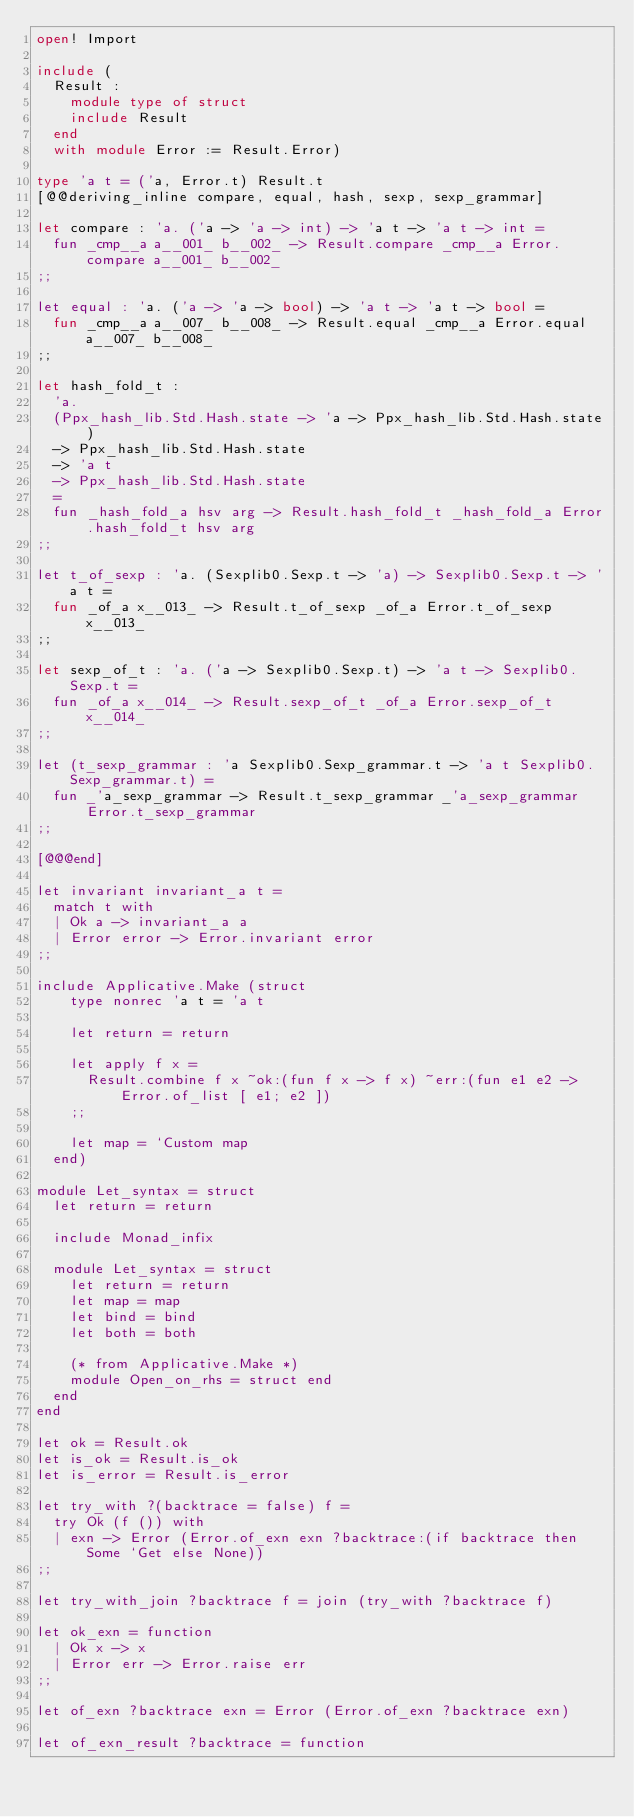<code> <loc_0><loc_0><loc_500><loc_500><_OCaml_>open! Import

include (
  Result :
    module type of struct
    include Result
  end
  with module Error := Result.Error)

type 'a t = ('a, Error.t) Result.t
[@@deriving_inline compare, equal, hash, sexp, sexp_grammar]

let compare : 'a. ('a -> 'a -> int) -> 'a t -> 'a t -> int =
  fun _cmp__a a__001_ b__002_ -> Result.compare _cmp__a Error.compare a__001_ b__002_
;;

let equal : 'a. ('a -> 'a -> bool) -> 'a t -> 'a t -> bool =
  fun _cmp__a a__007_ b__008_ -> Result.equal _cmp__a Error.equal a__007_ b__008_
;;

let hash_fold_t :
  'a.
  (Ppx_hash_lib.Std.Hash.state -> 'a -> Ppx_hash_lib.Std.Hash.state)
  -> Ppx_hash_lib.Std.Hash.state
  -> 'a t
  -> Ppx_hash_lib.Std.Hash.state
  =
  fun _hash_fold_a hsv arg -> Result.hash_fold_t _hash_fold_a Error.hash_fold_t hsv arg
;;

let t_of_sexp : 'a. (Sexplib0.Sexp.t -> 'a) -> Sexplib0.Sexp.t -> 'a t =
  fun _of_a x__013_ -> Result.t_of_sexp _of_a Error.t_of_sexp x__013_
;;

let sexp_of_t : 'a. ('a -> Sexplib0.Sexp.t) -> 'a t -> Sexplib0.Sexp.t =
  fun _of_a x__014_ -> Result.sexp_of_t _of_a Error.sexp_of_t x__014_
;;

let (t_sexp_grammar : 'a Sexplib0.Sexp_grammar.t -> 'a t Sexplib0.Sexp_grammar.t) =
  fun _'a_sexp_grammar -> Result.t_sexp_grammar _'a_sexp_grammar Error.t_sexp_grammar
;;

[@@@end]

let invariant invariant_a t =
  match t with
  | Ok a -> invariant_a a
  | Error error -> Error.invariant error
;;

include Applicative.Make (struct
    type nonrec 'a t = 'a t

    let return = return

    let apply f x =
      Result.combine f x ~ok:(fun f x -> f x) ~err:(fun e1 e2 -> Error.of_list [ e1; e2 ])
    ;;

    let map = `Custom map
  end)

module Let_syntax = struct
  let return = return

  include Monad_infix

  module Let_syntax = struct
    let return = return
    let map = map
    let bind = bind
    let both = both

    (* from Applicative.Make *)
    module Open_on_rhs = struct end
  end
end

let ok = Result.ok
let is_ok = Result.is_ok
let is_error = Result.is_error

let try_with ?(backtrace = false) f =
  try Ok (f ()) with
  | exn -> Error (Error.of_exn exn ?backtrace:(if backtrace then Some `Get else None))
;;

let try_with_join ?backtrace f = join (try_with ?backtrace f)

let ok_exn = function
  | Ok x -> x
  | Error err -> Error.raise err
;;

let of_exn ?backtrace exn = Error (Error.of_exn ?backtrace exn)

let of_exn_result ?backtrace = function</code> 